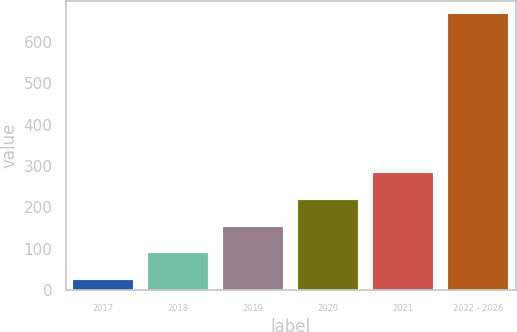Convert chart to OTSL. <chart><loc_0><loc_0><loc_500><loc_500><bar_chart><fcel>2017<fcel>2018<fcel>2019<fcel>2020<fcel>2021<fcel>2022 - 2026<nl><fcel>26<fcel>90<fcel>154<fcel>218<fcel>282<fcel>666<nl></chart> 